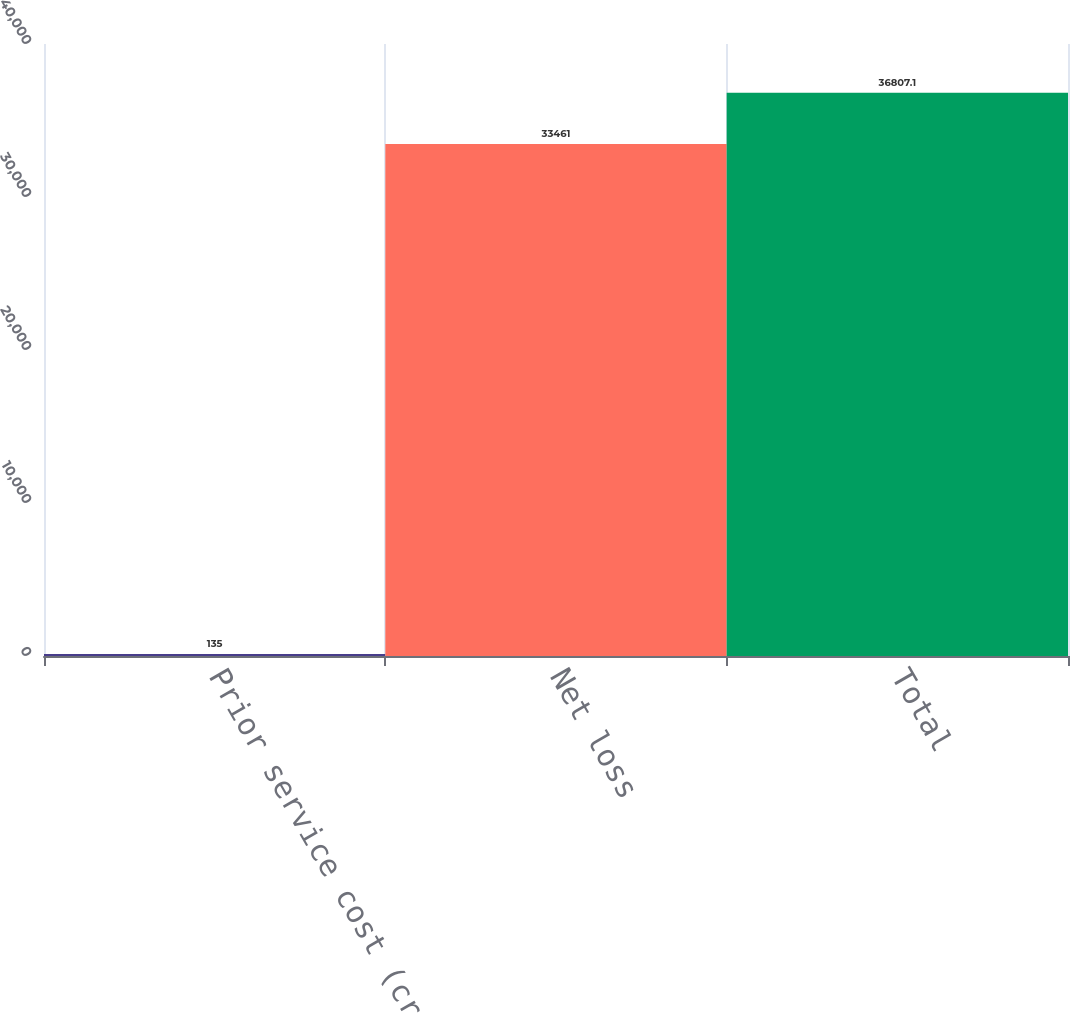<chart> <loc_0><loc_0><loc_500><loc_500><bar_chart><fcel>Prior service cost (credit)<fcel>Net loss<fcel>Total<nl><fcel>135<fcel>33461<fcel>36807.1<nl></chart> 